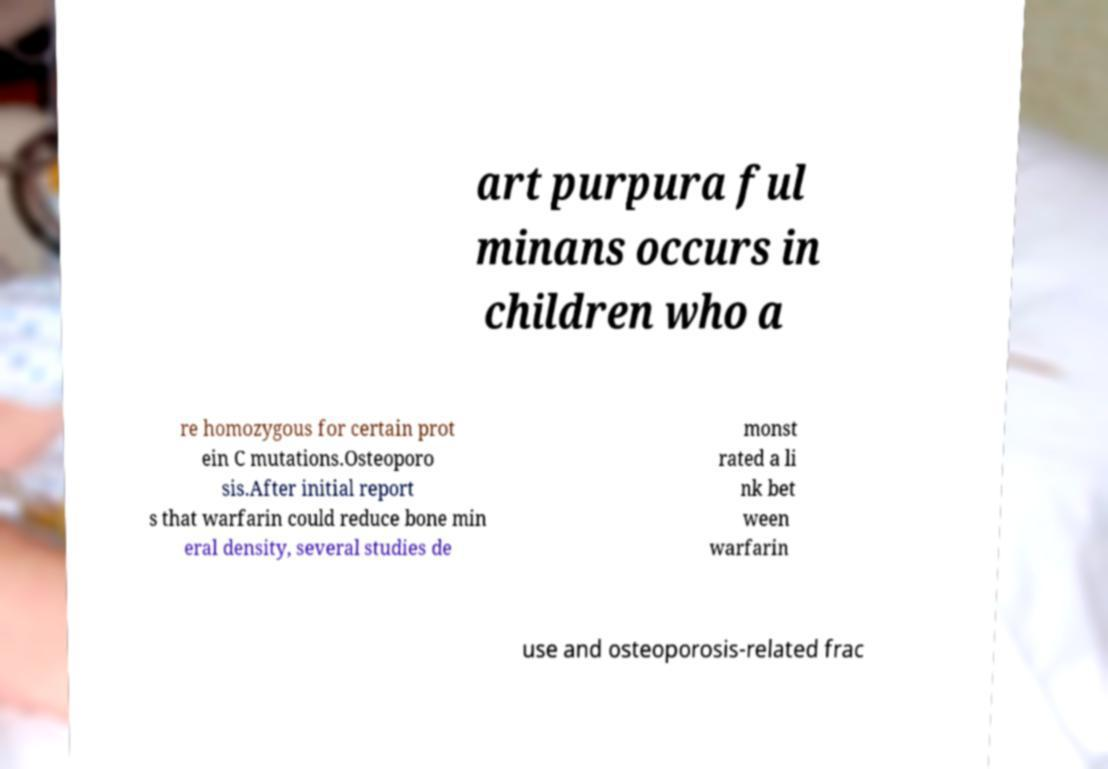What messages or text are displayed in this image? I need them in a readable, typed format. art purpura ful minans occurs in children who a re homozygous for certain prot ein C mutations.Osteoporo sis.After initial report s that warfarin could reduce bone min eral density, several studies de monst rated a li nk bet ween warfarin use and osteoporosis-related frac 